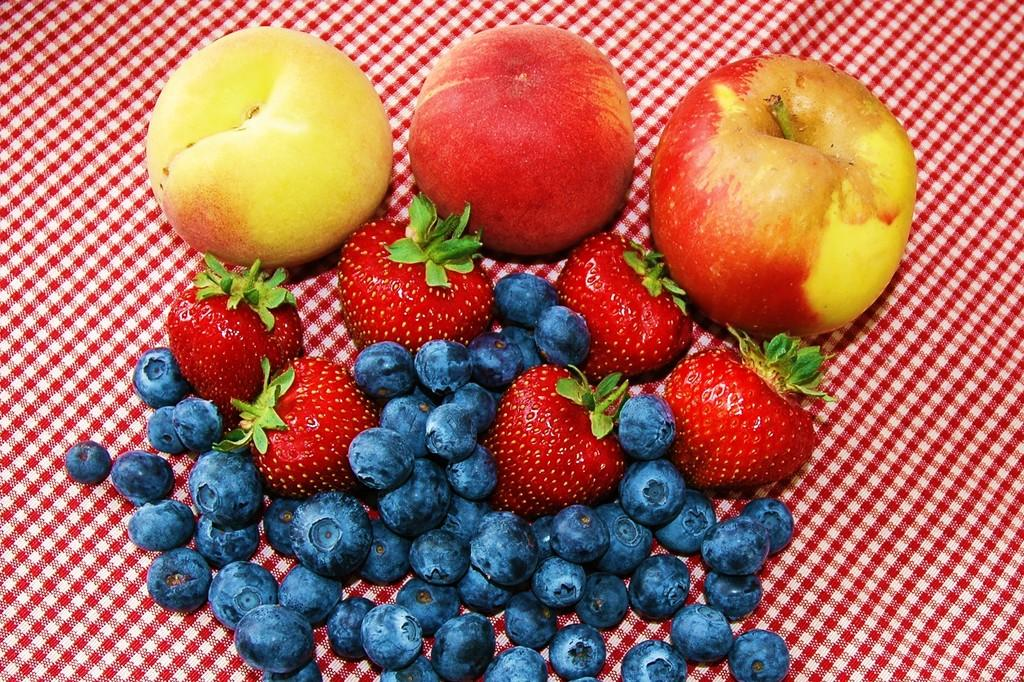What types of fruits are present in the image? There are apples, strawberries, and black color grapes in the image. Can you describe the color of the grapes? The grapes in the image are black in color. Are there any other fruits present in the image besides apples, strawberries, and grapes? No, the provided facts only mention apples, strawberries, and black color grapes in the image. What type of hope can be seen growing on the tree in the image? There is no tree or hope present in the image; it only features apples, strawberries, and black color grapes. Is there a jail visible in the image? No, there is no jail present in the image. 